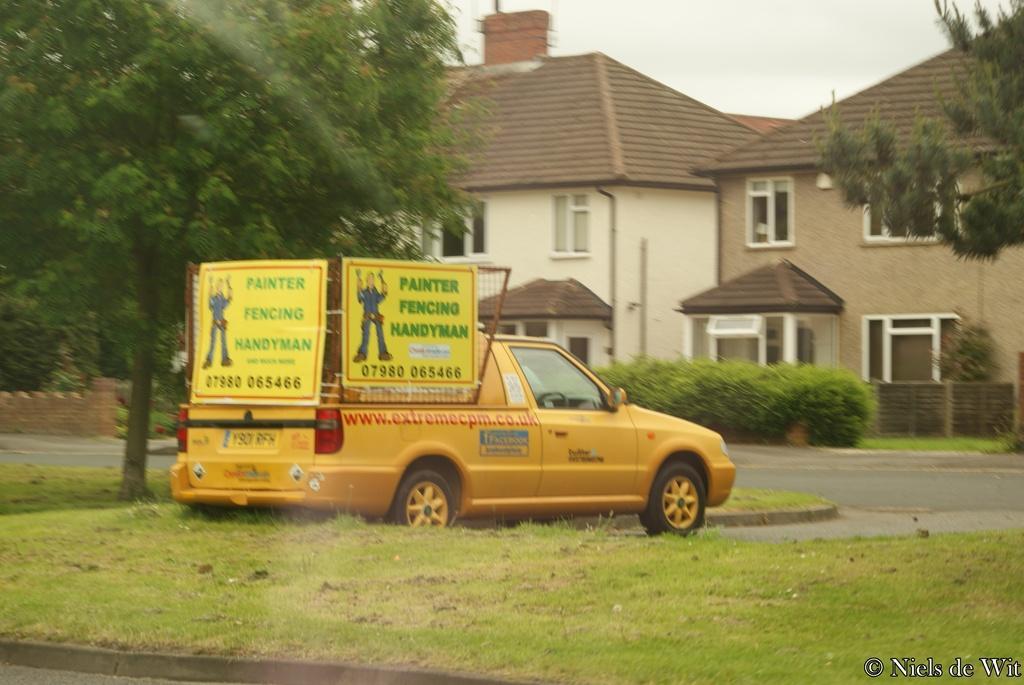In one or two sentences, can you explain what this image depicts? In this image I can see the yellow color vehicle on the grass. I can see the boards to the vehicle. In the background I can see many trees, houses with windows and the sky. 